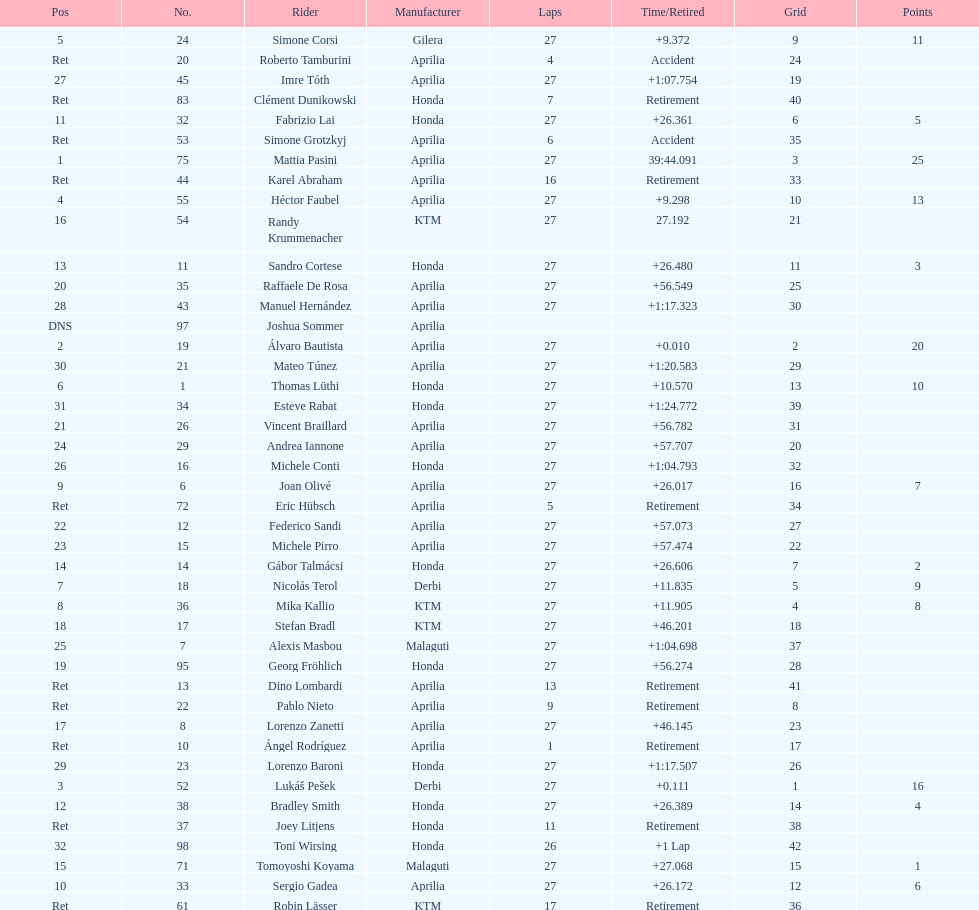Name a racer that had at least 20 points. Mattia Pasini. 